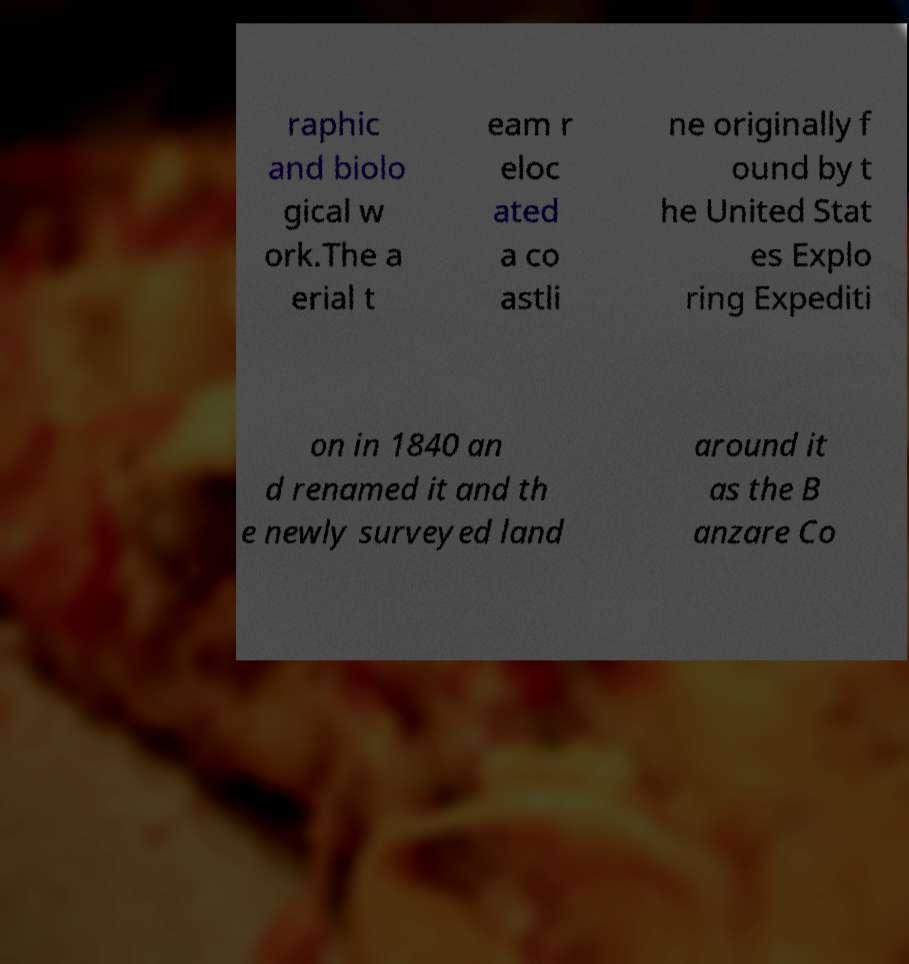There's text embedded in this image that I need extracted. Can you transcribe it verbatim? raphic and biolo gical w ork.The a erial t eam r eloc ated a co astli ne originally f ound by t he United Stat es Explo ring Expediti on in 1840 an d renamed it and th e newly surveyed land around it as the B anzare Co 